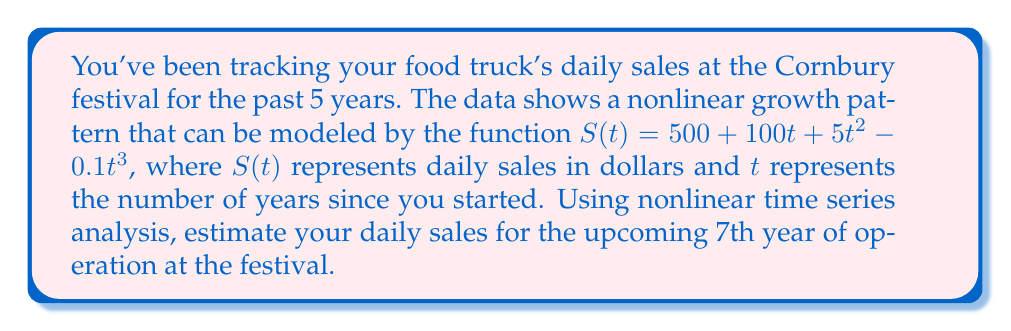Teach me how to tackle this problem. To estimate the daily sales for the 7th year, we need to evaluate the given function $S(t)$ at $t = 7$. Let's break this down step-by-step:

1) The given function is:
   $$S(t) = 500 + 100t + 5t^2 - 0.1t^3$$

2) We need to calculate $S(7)$. Let's substitute $t = 7$ into the equation:
   $$S(7) = 500 + 100(7) + 5(7)^2 - 0.1(7)^3$$

3) Let's evaluate each term:
   - $500$ remains as is
   - $100(7) = 700$
   - $5(7)^2 = 5(49) = 245$
   - $0.1(7)^3 = 0.1(343) = 34.3$

4) Now, let's combine these terms:
   $$S(7) = 500 + 700 + 245 - 34.3$$

5) Calculating the final result:
   $$S(7) = 1410.7$$

Therefore, the estimated daily sales for the 7th year of operation at the Cornbury festival is $1410.70.
Answer: $1410.70 